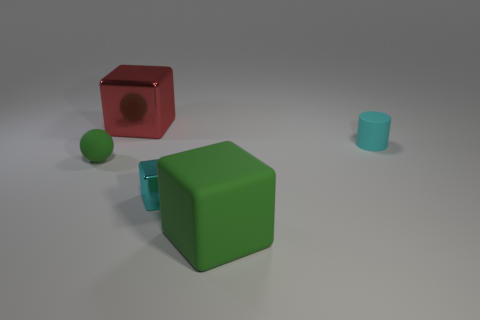Do the small thing that is on the right side of the matte block and the big rubber block have the same color?
Offer a terse response. No. Does the cyan cube have the same size as the red cube?
Your response must be concise. No. What is the shape of the cyan matte thing that is the same size as the matte sphere?
Your answer should be compact. Cylinder. Is the size of the rubber thing that is left of the matte cube the same as the big red block?
Ensure brevity in your answer.  No. There is a sphere that is the same size as the cyan metallic thing; what material is it?
Offer a very short reply. Rubber. Is there a tiny cyan cube that is left of the green matte object to the left of the metallic object right of the red metal cube?
Give a very brief answer. No. Is there any other thing that is the same shape as the big shiny object?
Your answer should be compact. Yes. There is a metal block left of the tiny cyan metal block; is it the same color as the metal block that is in front of the ball?
Keep it short and to the point. No. Are any large green things visible?
Keep it short and to the point. Yes. What is the material of the other thing that is the same color as the tiny shiny thing?
Your response must be concise. Rubber. 